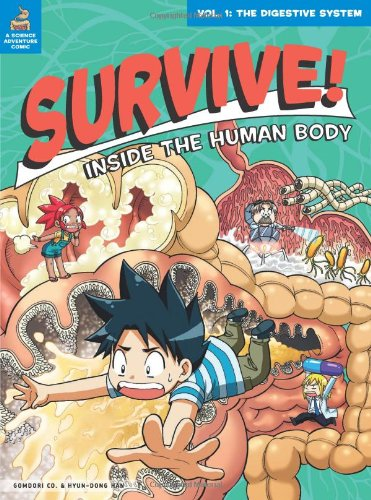What is the genre of this book? The genre of the book is Children's Books, focusing on educational content with a fun narrative approach to explaining the human digestive system. 